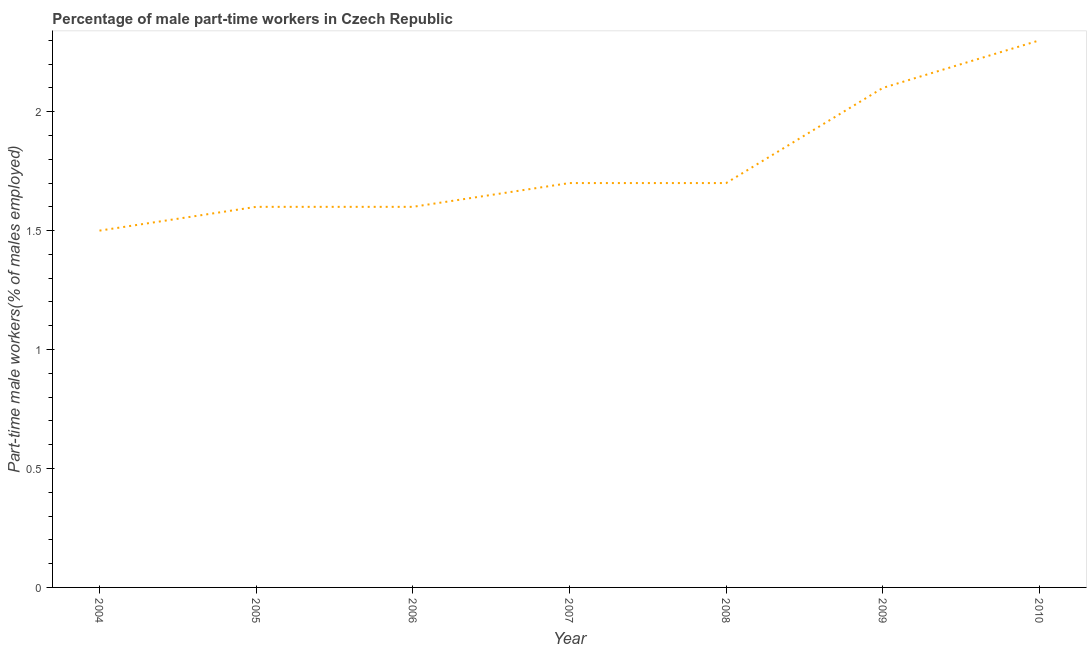What is the percentage of part-time male workers in 2010?
Ensure brevity in your answer.  2.3. Across all years, what is the maximum percentage of part-time male workers?
Your response must be concise. 2.3. What is the sum of the percentage of part-time male workers?
Keep it short and to the point. 12.5. What is the difference between the percentage of part-time male workers in 2004 and 2008?
Your answer should be very brief. -0.2. What is the average percentage of part-time male workers per year?
Provide a short and direct response. 1.79. What is the median percentage of part-time male workers?
Give a very brief answer. 1.7. In how many years, is the percentage of part-time male workers greater than 0.7 %?
Keep it short and to the point. 7. What is the ratio of the percentage of part-time male workers in 2006 to that in 2009?
Give a very brief answer. 0.76. Is the percentage of part-time male workers in 2007 less than that in 2008?
Your answer should be very brief. No. What is the difference between the highest and the second highest percentage of part-time male workers?
Provide a short and direct response. 0.2. Is the sum of the percentage of part-time male workers in 2006 and 2008 greater than the maximum percentage of part-time male workers across all years?
Keep it short and to the point. Yes. What is the difference between the highest and the lowest percentage of part-time male workers?
Make the answer very short. 0.8. In how many years, is the percentage of part-time male workers greater than the average percentage of part-time male workers taken over all years?
Your response must be concise. 2. How many lines are there?
Give a very brief answer. 1. How many years are there in the graph?
Your response must be concise. 7. What is the difference between two consecutive major ticks on the Y-axis?
Ensure brevity in your answer.  0.5. What is the title of the graph?
Your answer should be compact. Percentage of male part-time workers in Czech Republic. What is the label or title of the X-axis?
Offer a terse response. Year. What is the label or title of the Y-axis?
Provide a short and direct response. Part-time male workers(% of males employed). What is the Part-time male workers(% of males employed) of 2004?
Your answer should be compact. 1.5. What is the Part-time male workers(% of males employed) of 2005?
Provide a short and direct response. 1.6. What is the Part-time male workers(% of males employed) in 2006?
Provide a succinct answer. 1.6. What is the Part-time male workers(% of males employed) in 2007?
Make the answer very short. 1.7. What is the Part-time male workers(% of males employed) in 2008?
Provide a succinct answer. 1.7. What is the Part-time male workers(% of males employed) in 2009?
Offer a very short reply. 2.1. What is the Part-time male workers(% of males employed) in 2010?
Keep it short and to the point. 2.3. What is the difference between the Part-time male workers(% of males employed) in 2004 and 2005?
Provide a succinct answer. -0.1. What is the difference between the Part-time male workers(% of males employed) in 2004 and 2009?
Your answer should be compact. -0.6. What is the difference between the Part-time male workers(% of males employed) in 2004 and 2010?
Ensure brevity in your answer.  -0.8. What is the difference between the Part-time male workers(% of males employed) in 2005 and 2006?
Make the answer very short. 0. What is the difference between the Part-time male workers(% of males employed) in 2005 and 2007?
Your answer should be very brief. -0.1. What is the difference between the Part-time male workers(% of males employed) in 2005 and 2008?
Your answer should be very brief. -0.1. What is the difference between the Part-time male workers(% of males employed) in 2006 and 2007?
Make the answer very short. -0.1. What is the difference between the Part-time male workers(% of males employed) in 2006 and 2008?
Offer a terse response. -0.1. What is the difference between the Part-time male workers(% of males employed) in 2006 and 2009?
Provide a succinct answer. -0.5. What is the difference between the Part-time male workers(% of males employed) in 2008 and 2009?
Offer a terse response. -0.4. What is the difference between the Part-time male workers(% of males employed) in 2008 and 2010?
Keep it short and to the point. -0.6. What is the difference between the Part-time male workers(% of males employed) in 2009 and 2010?
Provide a short and direct response. -0.2. What is the ratio of the Part-time male workers(% of males employed) in 2004 to that in 2005?
Your response must be concise. 0.94. What is the ratio of the Part-time male workers(% of males employed) in 2004 to that in 2006?
Ensure brevity in your answer.  0.94. What is the ratio of the Part-time male workers(% of males employed) in 2004 to that in 2007?
Your answer should be compact. 0.88. What is the ratio of the Part-time male workers(% of males employed) in 2004 to that in 2008?
Your answer should be compact. 0.88. What is the ratio of the Part-time male workers(% of males employed) in 2004 to that in 2009?
Keep it short and to the point. 0.71. What is the ratio of the Part-time male workers(% of males employed) in 2004 to that in 2010?
Provide a succinct answer. 0.65. What is the ratio of the Part-time male workers(% of males employed) in 2005 to that in 2007?
Keep it short and to the point. 0.94. What is the ratio of the Part-time male workers(% of males employed) in 2005 to that in 2008?
Offer a very short reply. 0.94. What is the ratio of the Part-time male workers(% of males employed) in 2005 to that in 2009?
Provide a succinct answer. 0.76. What is the ratio of the Part-time male workers(% of males employed) in 2005 to that in 2010?
Offer a terse response. 0.7. What is the ratio of the Part-time male workers(% of males employed) in 2006 to that in 2007?
Your response must be concise. 0.94. What is the ratio of the Part-time male workers(% of males employed) in 2006 to that in 2008?
Make the answer very short. 0.94. What is the ratio of the Part-time male workers(% of males employed) in 2006 to that in 2009?
Provide a short and direct response. 0.76. What is the ratio of the Part-time male workers(% of males employed) in 2006 to that in 2010?
Offer a terse response. 0.7. What is the ratio of the Part-time male workers(% of males employed) in 2007 to that in 2009?
Offer a very short reply. 0.81. What is the ratio of the Part-time male workers(% of males employed) in 2007 to that in 2010?
Your answer should be compact. 0.74. What is the ratio of the Part-time male workers(% of males employed) in 2008 to that in 2009?
Provide a succinct answer. 0.81. What is the ratio of the Part-time male workers(% of males employed) in 2008 to that in 2010?
Give a very brief answer. 0.74. What is the ratio of the Part-time male workers(% of males employed) in 2009 to that in 2010?
Provide a succinct answer. 0.91. 